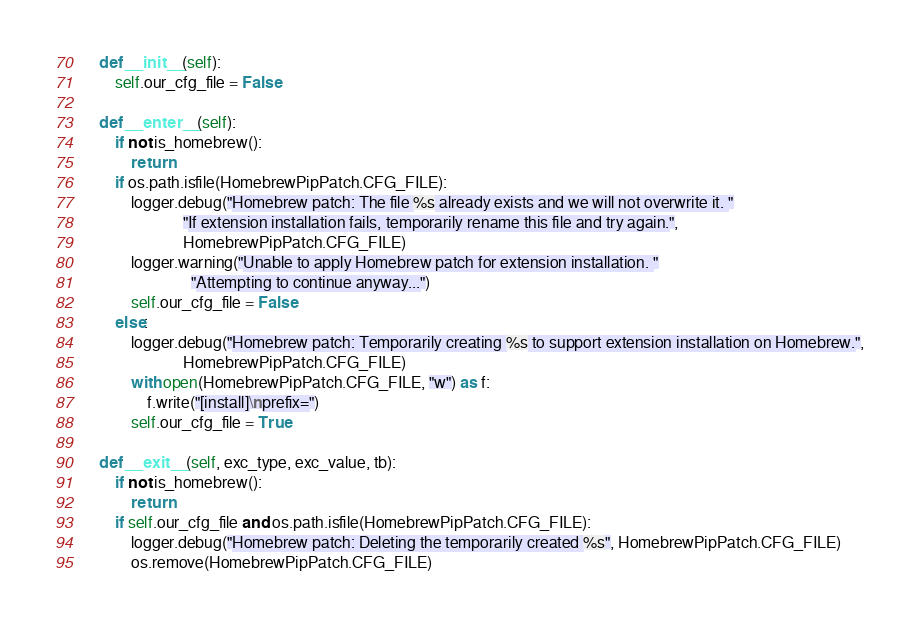Convert code to text. <code><loc_0><loc_0><loc_500><loc_500><_Python_>    def __init__(self):
        self.our_cfg_file = False

    def __enter__(self):
        if not is_homebrew():
            return
        if os.path.isfile(HomebrewPipPatch.CFG_FILE):
            logger.debug("Homebrew patch: The file %s already exists and we will not overwrite it. "
                         "If extension installation fails, temporarily rename this file and try again.",
                         HomebrewPipPatch.CFG_FILE)
            logger.warning("Unable to apply Homebrew patch for extension installation. "
                           "Attempting to continue anyway...")
            self.our_cfg_file = False
        else:
            logger.debug("Homebrew patch: Temporarily creating %s to support extension installation on Homebrew.",
                         HomebrewPipPatch.CFG_FILE)
            with open(HomebrewPipPatch.CFG_FILE, "w") as f:
                f.write("[install]\nprefix=")
            self.our_cfg_file = True

    def __exit__(self, exc_type, exc_value, tb):
        if not is_homebrew():
            return
        if self.our_cfg_file and os.path.isfile(HomebrewPipPatch.CFG_FILE):
            logger.debug("Homebrew patch: Deleting the temporarily created %s", HomebrewPipPatch.CFG_FILE)
            os.remove(HomebrewPipPatch.CFG_FILE)
</code> 